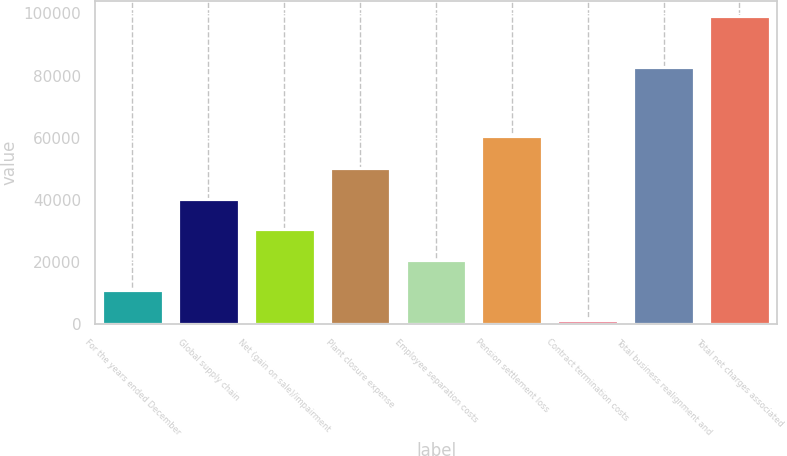Convert chart to OTSL. <chart><loc_0><loc_0><loc_500><loc_500><bar_chart><fcel>For the years ended December<fcel>Global supply chain<fcel>Net (gain on sale)/impairment<fcel>Plant closure expense<fcel>Employee separation costs<fcel>Pension settlement loss<fcel>Contract termination costs<fcel>Total business realignment and<fcel>Total net charges associated<nl><fcel>11021<fcel>40391<fcel>30601<fcel>50181<fcel>20811<fcel>60431<fcel>1231<fcel>82875<fcel>99131<nl></chart> 